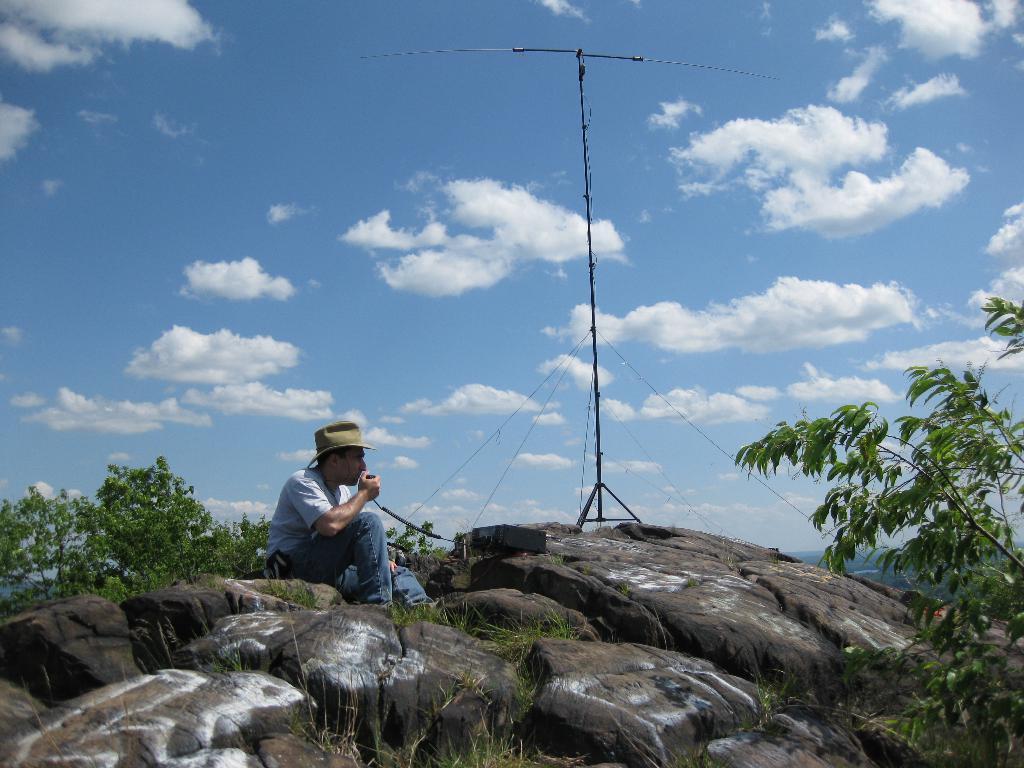Please provide a concise description of this image. In this image there is a person sitting on the mountain and holding an object. On the left and right side of the image there are trees. In the background there is like a utility pole and the sky. 